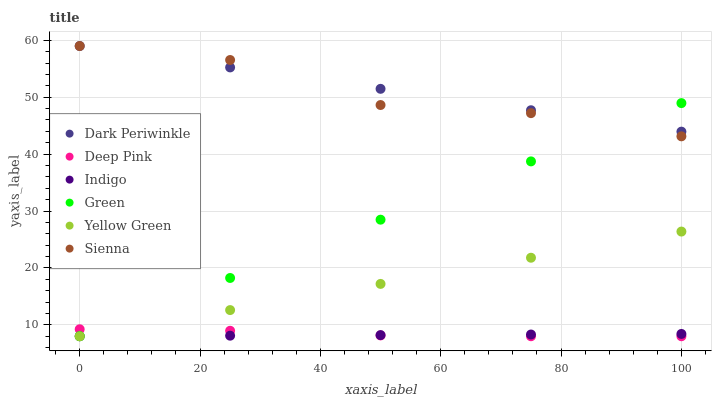Does Indigo have the minimum area under the curve?
Answer yes or no. Yes. Does Dark Periwinkle have the maximum area under the curve?
Answer yes or no. Yes. Does Yellow Green have the minimum area under the curve?
Answer yes or no. No. Does Yellow Green have the maximum area under the curve?
Answer yes or no. No. Is Indigo the smoothest?
Answer yes or no. Yes. Is Sienna the roughest?
Answer yes or no. Yes. Is Yellow Green the smoothest?
Answer yes or no. No. Is Yellow Green the roughest?
Answer yes or no. No. Does Deep Pink have the lowest value?
Answer yes or no. Yes. Does Sienna have the lowest value?
Answer yes or no. No. Does Dark Periwinkle have the highest value?
Answer yes or no. Yes. Does Yellow Green have the highest value?
Answer yes or no. No. Is Yellow Green less than Sienna?
Answer yes or no. Yes. Is Sienna greater than Indigo?
Answer yes or no. Yes. Does Deep Pink intersect Yellow Green?
Answer yes or no. Yes. Is Deep Pink less than Yellow Green?
Answer yes or no. No. Is Deep Pink greater than Yellow Green?
Answer yes or no. No. Does Yellow Green intersect Sienna?
Answer yes or no. No. 